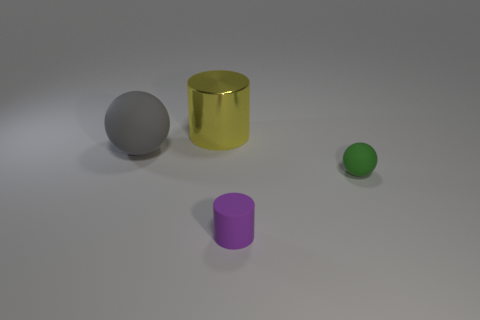Add 1 large gray spheres. How many objects exist? 5 Subtract all small green metallic cylinders. Subtract all gray objects. How many objects are left? 3 Add 3 large yellow shiny things. How many large yellow shiny things are left? 4 Add 4 gray matte things. How many gray matte things exist? 5 Subtract 0 gray cylinders. How many objects are left? 4 